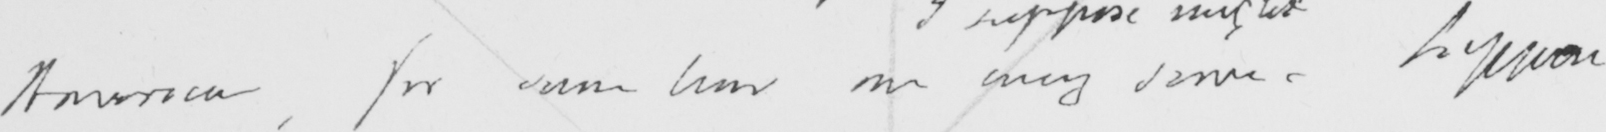Can you read and transcribe this handwriting? America , for some time one envy same . Suppose 